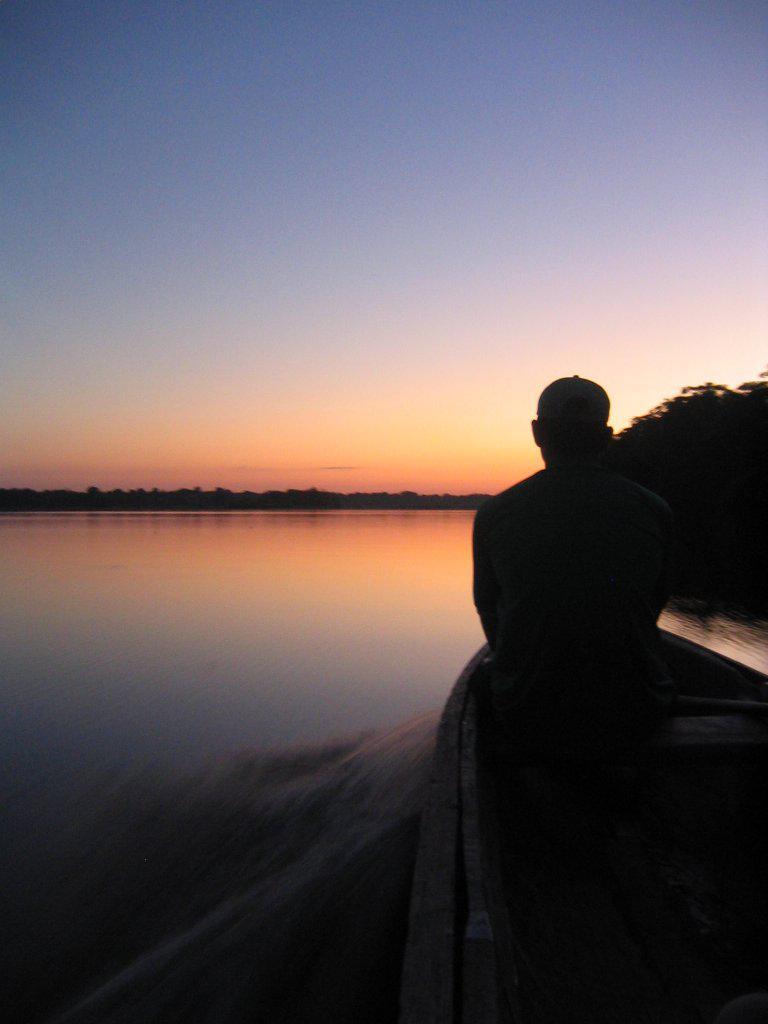Can you describe this image briefly? In this image we can see a river and there is a boat on the river. We can see a person sitting in the boat. In the background there are trees and sky. 